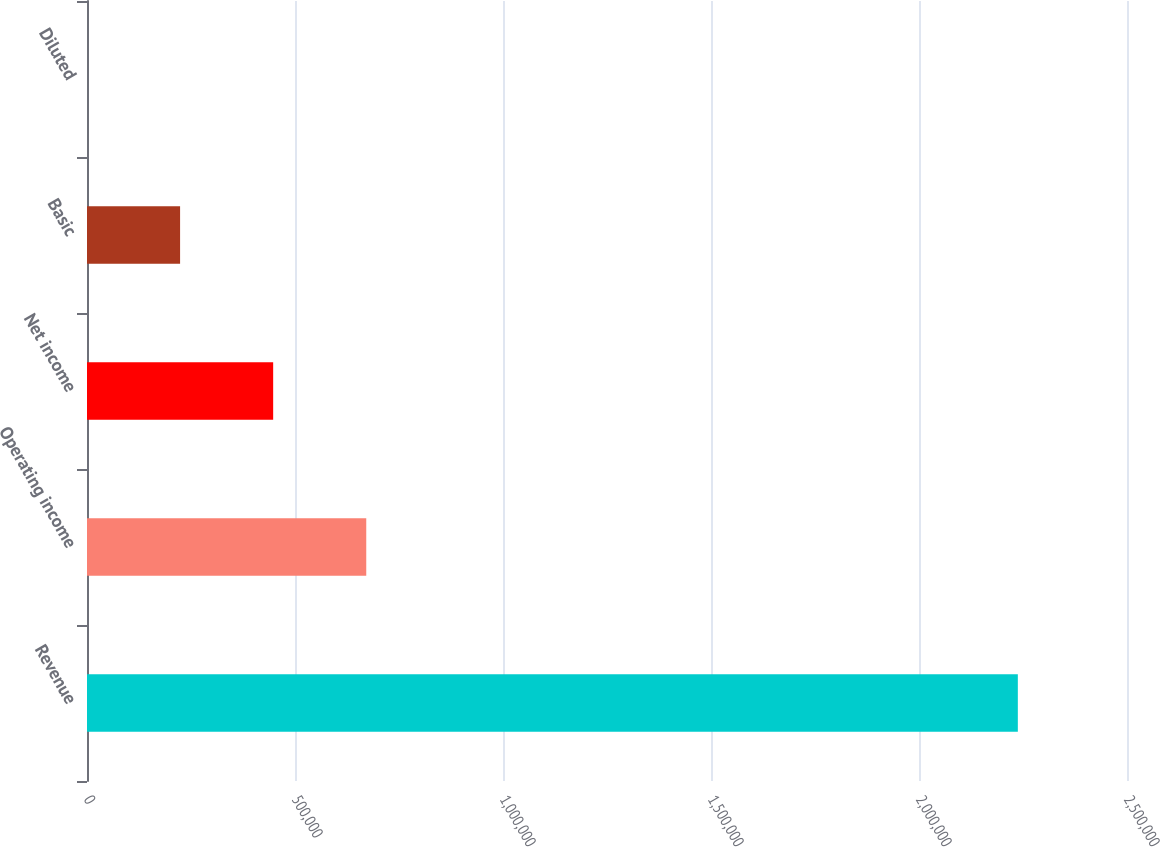<chart> <loc_0><loc_0><loc_500><loc_500><bar_chart><fcel>Revenue<fcel>Operating income<fcel>Net income<fcel>Basic<fcel>Diluted<nl><fcel>2.23759e+06<fcel>671276<fcel>447518<fcel>223759<fcel>0.7<nl></chart> 